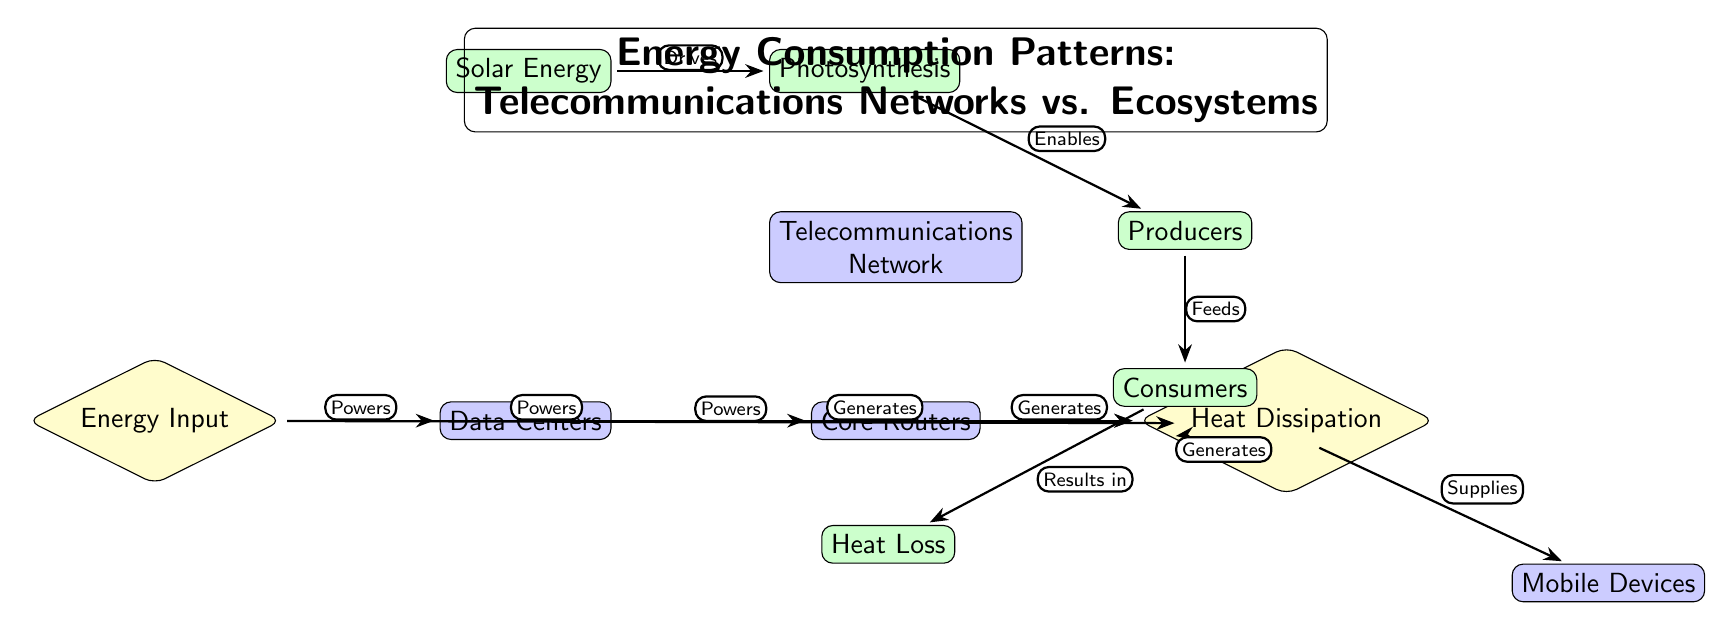What nodes are powered by Energy Input? The Energy Input node points to three nodes: Data Centers, Core Routers, and Edge Routers, indicating that these components are powered by the energy input.
Answer: Data Centers, Core Routers, Edge Routers What do Data Centers generate? The Data Centers node has an outgoing arrow labeled "Generates" pointing to the Heat Dissipation node, indicating that the Data Centers produce heat as a byproduct of their function.
Answer: Heat Dissipation How many main nodes represent the ecosystem? The diagram includes five nodes that clearly represent different aspects of the ecosystem, specifically Solar Energy, Photosynthesis, Producers, Consumers, and Heat Loss.
Answer: 5 What relationship exists between Producers and Consumers? The Producers node is directly connected to the Consumers node by an arrow labeled "Feeds," which shows that Producers provide resources or support to Consumers in the ecosystem.
Answer: Feeds If the Heat Loss is considered a resultant effect in the ecosystem, what does it relate to? The Heat Loss node has an incoming arrow from the Consumers node, indicating that Heat Loss is a result of processes involving Consumers, specifically their activities in the ecosystem.
Answer: Results in What drives Photosynthesis in the diagram? The arrow going from the Solar Energy node to the Photosynthesis node is labeled "Drives," which signifies that the presence of solar energy initiates or enables the process of photosynthesis.
Answer: Drives What is the role of Mobile Devices in the Telecommunications Network? The Mobile Devices node is part of the network flow and receives energy through the Edge Routers node, signifying that it depends on the network for functionality and connectivity.
Answer: Supplies How does the Core Routers interact with Heat Dissipation? Core Routers generate heat, as indicated by the connection labeled "Generates" pointing to the Heat Dissipation node, showing that Core Routers contribute to thermal energy release in the system.
Answer: Generates Which component is at the top of the Telecommunications Network hierarchy? The Telecommunications Network node is the central parent node in this diagram, representing the overall system that encompasses all other components related to telecommunications.
Answer: Telecommunications Network 